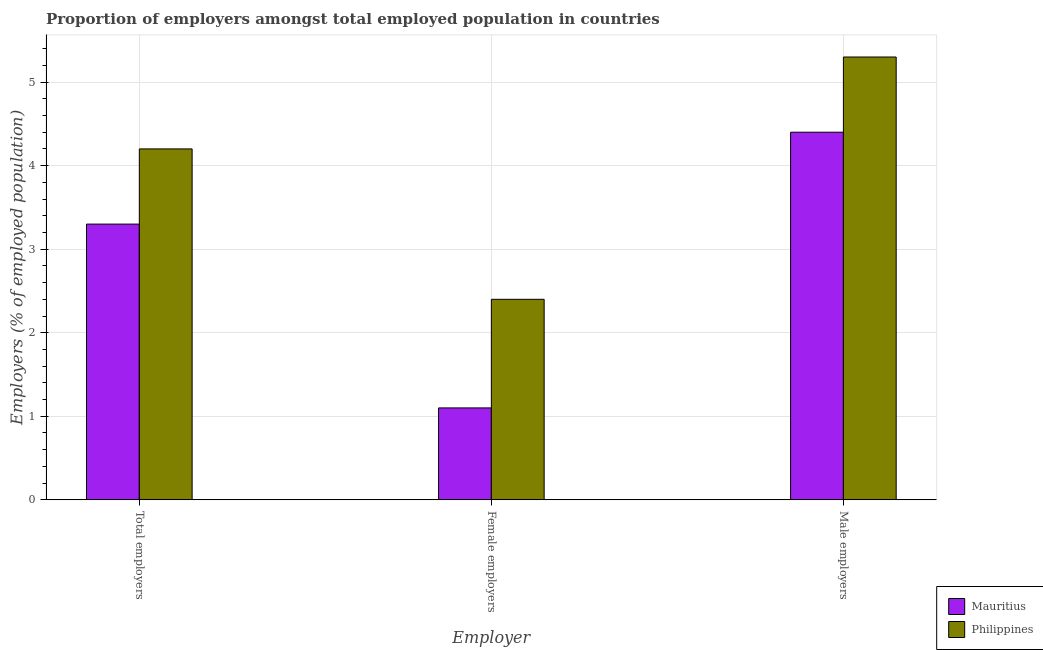How many different coloured bars are there?
Ensure brevity in your answer.  2. How many groups of bars are there?
Provide a short and direct response. 3. Are the number of bars per tick equal to the number of legend labels?
Your answer should be very brief. Yes. How many bars are there on the 3rd tick from the left?
Offer a very short reply. 2. What is the label of the 1st group of bars from the left?
Offer a terse response. Total employers. What is the percentage of male employers in Mauritius?
Provide a succinct answer. 4.4. Across all countries, what is the maximum percentage of female employers?
Your answer should be compact. 2.4. Across all countries, what is the minimum percentage of male employers?
Ensure brevity in your answer.  4.4. In which country was the percentage of female employers minimum?
Offer a terse response. Mauritius. What is the total percentage of female employers in the graph?
Provide a succinct answer. 3.5. What is the difference between the percentage of total employers in Mauritius and that in Philippines?
Give a very brief answer. -0.9. What is the difference between the percentage of male employers in Mauritius and the percentage of total employers in Philippines?
Provide a succinct answer. 0.2. What is the average percentage of total employers per country?
Ensure brevity in your answer.  3.75. What is the difference between the percentage of female employers and percentage of total employers in Mauritius?
Provide a succinct answer. -2.2. What is the ratio of the percentage of male employers in Mauritius to that in Philippines?
Ensure brevity in your answer.  0.83. Is the difference between the percentage of total employers in Philippines and Mauritius greater than the difference between the percentage of male employers in Philippines and Mauritius?
Keep it short and to the point. No. What is the difference between the highest and the second highest percentage of male employers?
Provide a short and direct response. 0.9. What is the difference between the highest and the lowest percentage of female employers?
Give a very brief answer. 1.3. In how many countries, is the percentage of female employers greater than the average percentage of female employers taken over all countries?
Provide a succinct answer. 1. What does the 2nd bar from the left in Male employers represents?
Your answer should be very brief. Philippines. Is it the case that in every country, the sum of the percentage of total employers and percentage of female employers is greater than the percentage of male employers?
Ensure brevity in your answer.  No. How many countries are there in the graph?
Offer a terse response. 2. Are the values on the major ticks of Y-axis written in scientific E-notation?
Make the answer very short. No. Does the graph contain grids?
Keep it short and to the point. Yes. How are the legend labels stacked?
Your answer should be compact. Vertical. What is the title of the graph?
Give a very brief answer. Proportion of employers amongst total employed population in countries. Does "Uganda" appear as one of the legend labels in the graph?
Your answer should be compact. No. What is the label or title of the X-axis?
Your response must be concise. Employer. What is the label or title of the Y-axis?
Give a very brief answer. Employers (% of employed population). What is the Employers (% of employed population) in Mauritius in Total employers?
Offer a terse response. 3.3. What is the Employers (% of employed population) of Philippines in Total employers?
Ensure brevity in your answer.  4.2. What is the Employers (% of employed population) of Mauritius in Female employers?
Your answer should be compact. 1.1. What is the Employers (% of employed population) of Philippines in Female employers?
Ensure brevity in your answer.  2.4. What is the Employers (% of employed population) in Mauritius in Male employers?
Your response must be concise. 4.4. What is the Employers (% of employed population) in Philippines in Male employers?
Provide a succinct answer. 5.3. Across all Employer, what is the maximum Employers (% of employed population) of Mauritius?
Offer a very short reply. 4.4. Across all Employer, what is the maximum Employers (% of employed population) in Philippines?
Provide a succinct answer. 5.3. Across all Employer, what is the minimum Employers (% of employed population) in Mauritius?
Offer a terse response. 1.1. Across all Employer, what is the minimum Employers (% of employed population) of Philippines?
Keep it short and to the point. 2.4. What is the total Employers (% of employed population) of Philippines in the graph?
Ensure brevity in your answer.  11.9. What is the difference between the Employers (% of employed population) of Philippines in Total employers and that in Male employers?
Your response must be concise. -1.1. What is the difference between the Employers (% of employed population) of Philippines in Female employers and that in Male employers?
Your answer should be compact. -2.9. What is the difference between the Employers (% of employed population) in Mauritius in Total employers and the Employers (% of employed population) in Philippines in Male employers?
Make the answer very short. -2. What is the average Employers (% of employed population) of Mauritius per Employer?
Your answer should be very brief. 2.93. What is the average Employers (% of employed population) in Philippines per Employer?
Offer a very short reply. 3.97. What is the difference between the Employers (% of employed population) of Mauritius and Employers (% of employed population) of Philippines in Total employers?
Give a very brief answer. -0.9. What is the difference between the Employers (% of employed population) of Mauritius and Employers (% of employed population) of Philippines in Female employers?
Give a very brief answer. -1.3. What is the difference between the Employers (% of employed population) of Mauritius and Employers (% of employed population) of Philippines in Male employers?
Make the answer very short. -0.9. What is the ratio of the Employers (% of employed population) of Mauritius in Total employers to that in Female employers?
Your answer should be very brief. 3. What is the ratio of the Employers (% of employed population) of Philippines in Total employers to that in Female employers?
Your answer should be compact. 1.75. What is the ratio of the Employers (% of employed population) in Philippines in Total employers to that in Male employers?
Your response must be concise. 0.79. What is the ratio of the Employers (% of employed population) in Philippines in Female employers to that in Male employers?
Ensure brevity in your answer.  0.45. What is the difference between the highest and the second highest Employers (% of employed population) of Mauritius?
Make the answer very short. 1.1. What is the difference between the highest and the second highest Employers (% of employed population) in Philippines?
Make the answer very short. 1.1. What is the difference between the highest and the lowest Employers (% of employed population) in Mauritius?
Your response must be concise. 3.3. What is the difference between the highest and the lowest Employers (% of employed population) of Philippines?
Keep it short and to the point. 2.9. 